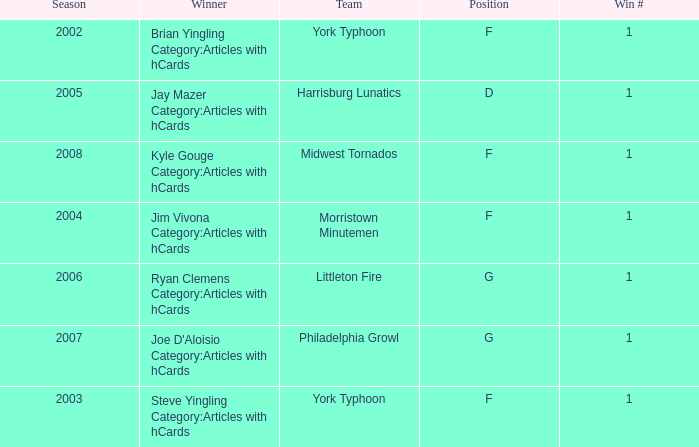Who was the winner in the 2008 season? Kyle Gouge Category:Articles with hCards. 